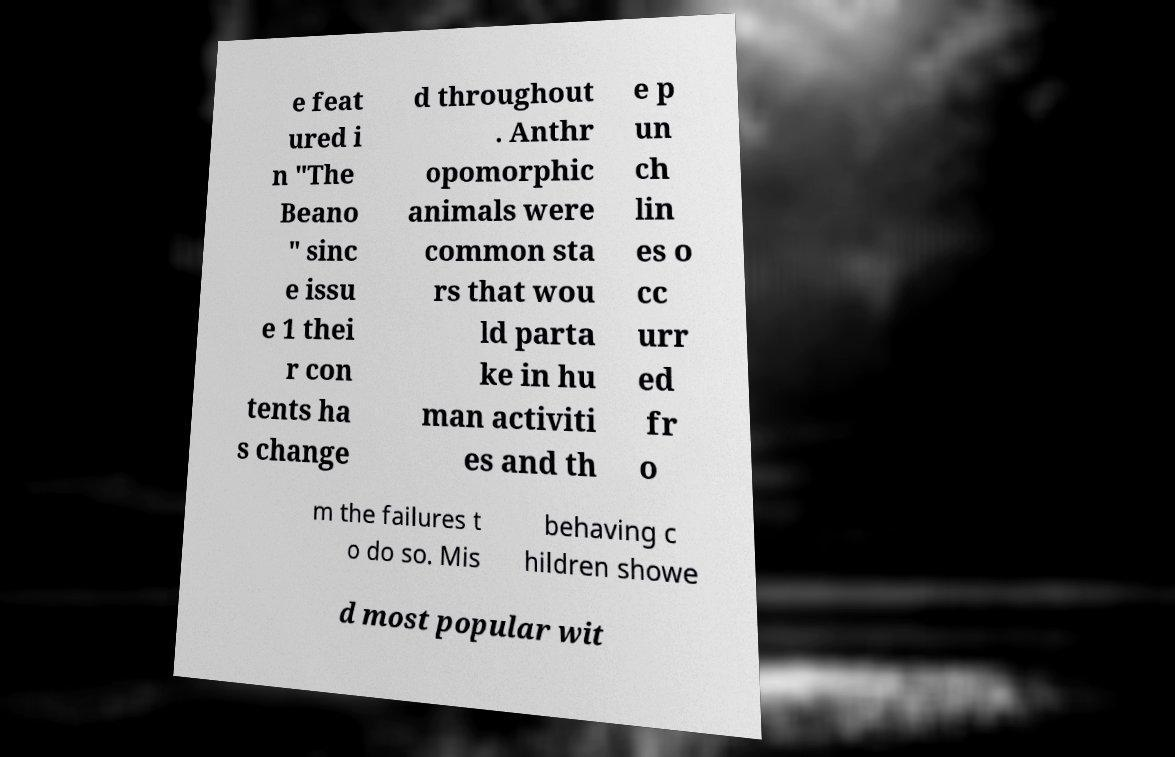Can you read and provide the text displayed in the image?This photo seems to have some interesting text. Can you extract and type it out for me? e feat ured i n "The Beano " sinc e issu e 1 thei r con tents ha s change d throughout . Anthr opomorphic animals were common sta rs that wou ld parta ke in hu man activiti es and th e p un ch lin es o cc urr ed fr o m the failures t o do so. Mis behaving c hildren showe d most popular wit 